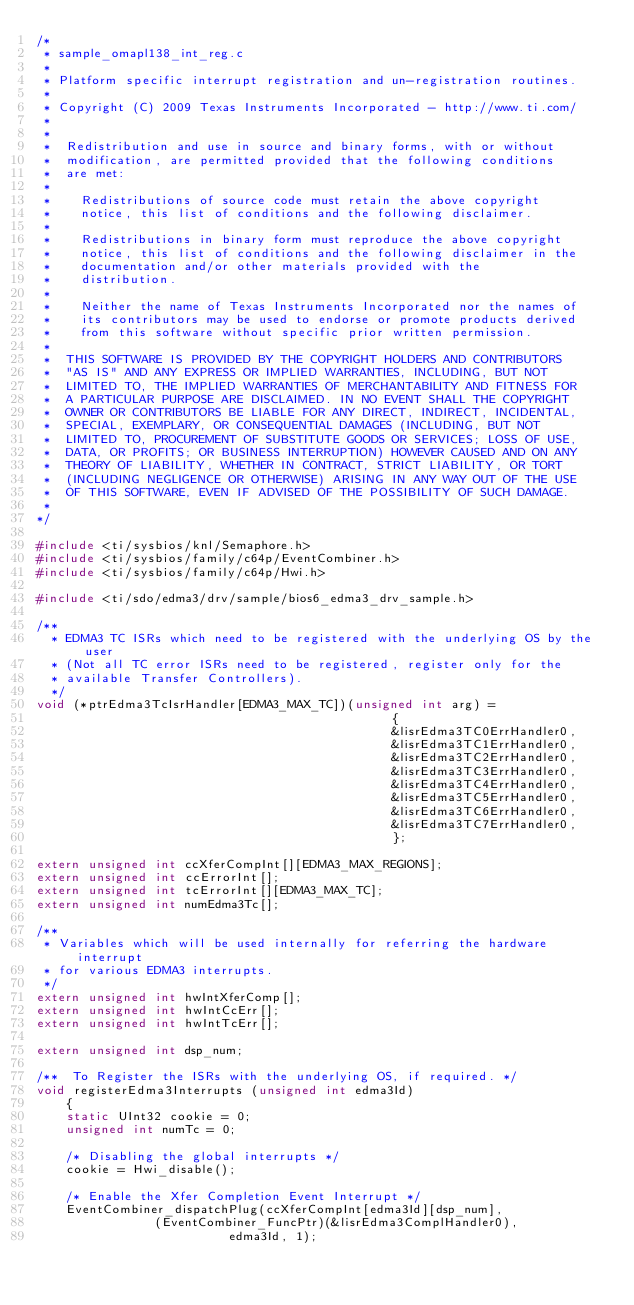Convert code to text. <code><loc_0><loc_0><loc_500><loc_500><_C_>/*
 * sample_omapl138_int_reg.c
 *
 * Platform specific interrupt registration and un-registration routines.
 *
 * Copyright (C) 2009 Texas Instruments Incorporated - http://www.ti.com/
 *
 *
 *  Redistribution and use in source and binary forms, with or without
 *  modification, are permitted provided that the following conditions
 *  are met:
 *
 *    Redistributions of source code must retain the above copyright
 *    notice, this list of conditions and the following disclaimer.
 *
 *    Redistributions in binary form must reproduce the above copyright
 *    notice, this list of conditions and the following disclaimer in the
 *    documentation and/or other materials provided with the
 *    distribution.
 *
 *    Neither the name of Texas Instruments Incorporated nor the names of
 *    its contributors may be used to endorse or promote products derived
 *    from this software without specific prior written permission.
 *
 *  THIS SOFTWARE IS PROVIDED BY THE COPYRIGHT HOLDERS AND CONTRIBUTORS
 *  "AS IS" AND ANY EXPRESS OR IMPLIED WARRANTIES, INCLUDING, BUT NOT
 *  LIMITED TO, THE IMPLIED WARRANTIES OF MERCHANTABILITY AND FITNESS FOR
 *  A PARTICULAR PURPOSE ARE DISCLAIMED. IN NO EVENT SHALL THE COPYRIGHT
 *  OWNER OR CONTRIBUTORS BE LIABLE FOR ANY DIRECT, INDIRECT, INCIDENTAL,
 *  SPECIAL, EXEMPLARY, OR CONSEQUENTIAL DAMAGES (INCLUDING, BUT NOT
 *  LIMITED TO, PROCUREMENT OF SUBSTITUTE GOODS OR SERVICES; LOSS OF USE,
 *  DATA, OR PROFITS; OR BUSINESS INTERRUPTION) HOWEVER CAUSED AND ON ANY
 *  THEORY OF LIABILITY, WHETHER IN CONTRACT, STRICT LIABILITY, OR TORT
 *  (INCLUDING NEGLIGENCE OR OTHERWISE) ARISING IN ANY WAY OUT OF THE USE
 *  OF THIS SOFTWARE, EVEN IF ADVISED OF THE POSSIBILITY OF SUCH DAMAGE.
 *
*/

#include <ti/sysbios/knl/Semaphore.h>
#include <ti/sysbios/family/c64p/EventCombiner.h>
#include <ti/sysbios/family/c64p/Hwi.h>

#include <ti/sdo/edma3/drv/sample/bios6_edma3_drv_sample.h>

/**
  * EDMA3 TC ISRs which need to be registered with the underlying OS by the user
  * (Not all TC error ISRs need to be registered, register only for the
  * available Transfer Controllers).
  */
void (*ptrEdma3TcIsrHandler[EDMA3_MAX_TC])(unsigned int arg) =
                                                {
                                                &lisrEdma3TC0ErrHandler0,
                                                &lisrEdma3TC1ErrHandler0,
                                                &lisrEdma3TC2ErrHandler0,
                                                &lisrEdma3TC3ErrHandler0,
                                                &lisrEdma3TC4ErrHandler0,
                                                &lisrEdma3TC5ErrHandler0,
                                                &lisrEdma3TC6ErrHandler0,
                                                &lisrEdma3TC7ErrHandler0,
                                                };

extern unsigned int ccXferCompInt[][EDMA3_MAX_REGIONS];
extern unsigned int ccErrorInt[];
extern unsigned int tcErrorInt[][EDMA3_MAX_TC];
extern unsigned int numEdma3Tc[];

/**
 * Variables which will be used internally for referring the hardware interrupt
 * for various EDMA3 interrupts.
 */
extern unsigned int hwIntXferComp[];
extern unsigned int hwIntCcErr[];
extern unsigned int hwIntTcErr[];

extern unsigned int dsp_num;

/**  To Register the ISRs with the underlying OS, if required. */
void registerEdma3Interrupts (unsigned int edma3Id)
    {
    static UInt32 cookie = 0;
    unsigned int numTc = 0;

    /* Disabling the global interrupts */
    cookie = Hwi_disable();

    /* Enable the Xfer Completion Event Interrupt */
    EventCombiner_dispatchPlug(ccXferCompInt[edma3Id][dsp_num],
    						(EventCombiner_FuncPtr)(&lisrEdma3ComplHandler0),
                        	edma3Id, 1);</code> 